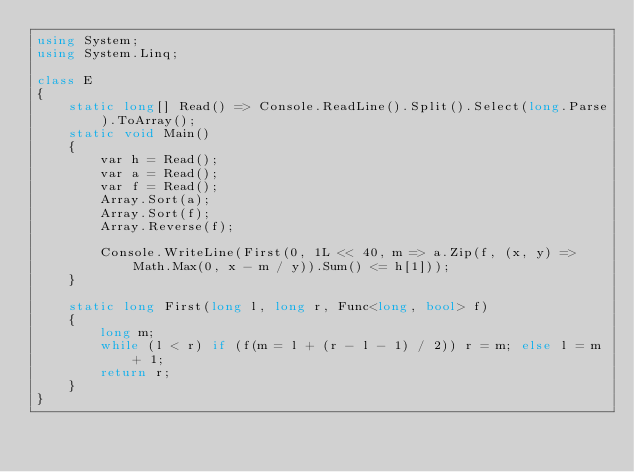Convert code to text. <code><loc_0><loc_0><loc_500><loc_500><_C#_>using System;
using System.Linq;

class E
{
	static long[] Read() => Console.ReadLine().Split().Select(long.Parse).ToArray();
	static void Main()
	{
		var h = Read();
		var a = Read();
		var f = Read();
		Array.Sort(a);
		Array.Sort(f);
		Array.Reverse(f);

		Console.WriteLine(First(0, 1L << 40, m => a.Zip(f, (x, y) => Math.Max(0, x - m / y)).Sum() <= h[1]));
	}

	static long First(long l, long r, Func<long, bool> f)
	{
		long m;
		while (l < r) if (f(m = l + (r - l - 1) / 2)) r = m; else l = m + 1;
		return r;
	}
}
</code> 